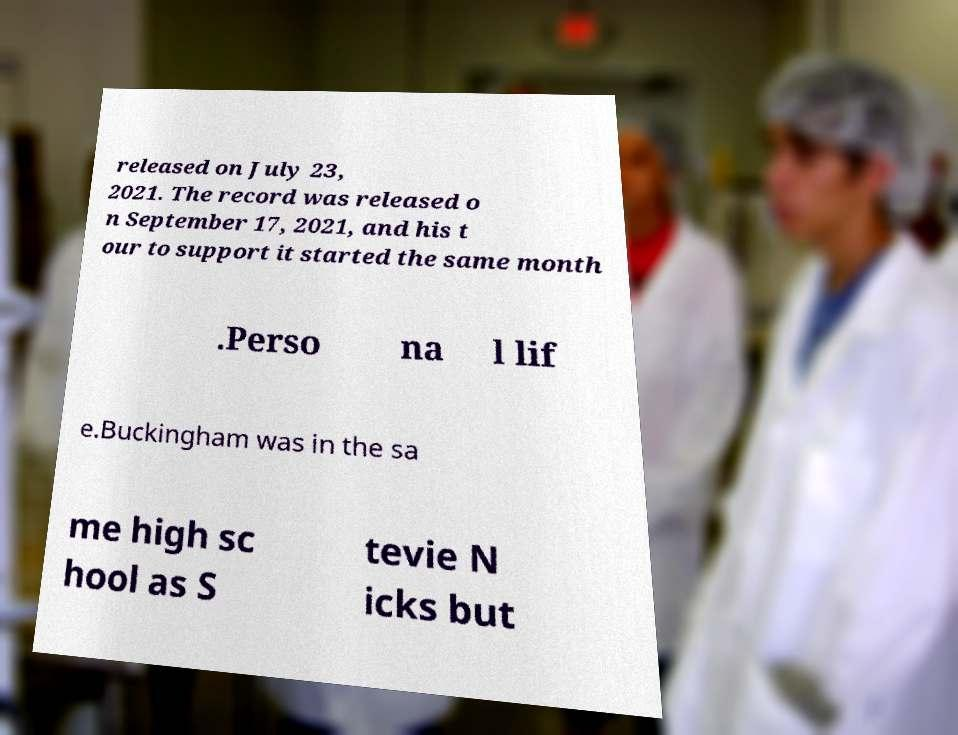Can you read and provide the text displayed in the image?This photo seems to have some interesting text. Can you extract and type it out for me? released on July 23, 2021. The record was released o n September 17, 2021, and his t our to support it started the same month .Perso na l lif e.Buckingham was in the sa me high sc hool as S tevie N icks but 